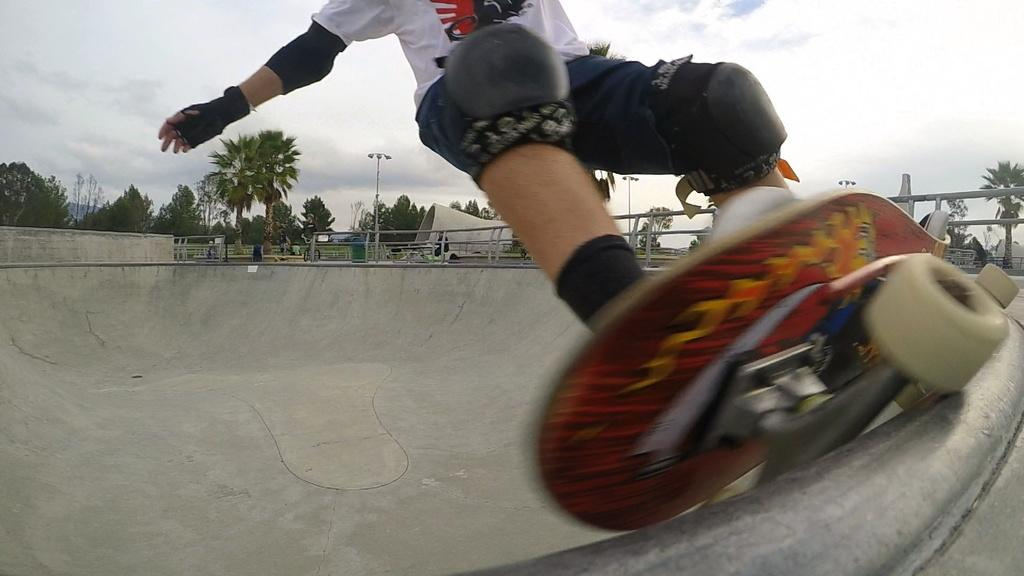Where was the image taken? The image was clicked outside. What can be seen in the middle of the image? There are trees in the middle of the image. What is visible at the top of the image? There is sky visible at the top of the image. What is the person in the image doing? The person is skating on a skateboard. What protective gear is the person wearing? The person is wearing gloves. What type of feast is being prepared in the image? There is no feast being prepared in the image; it features a person skating on a skateboard outside. Can you see any rats in the image? There are no rats present in the image. 